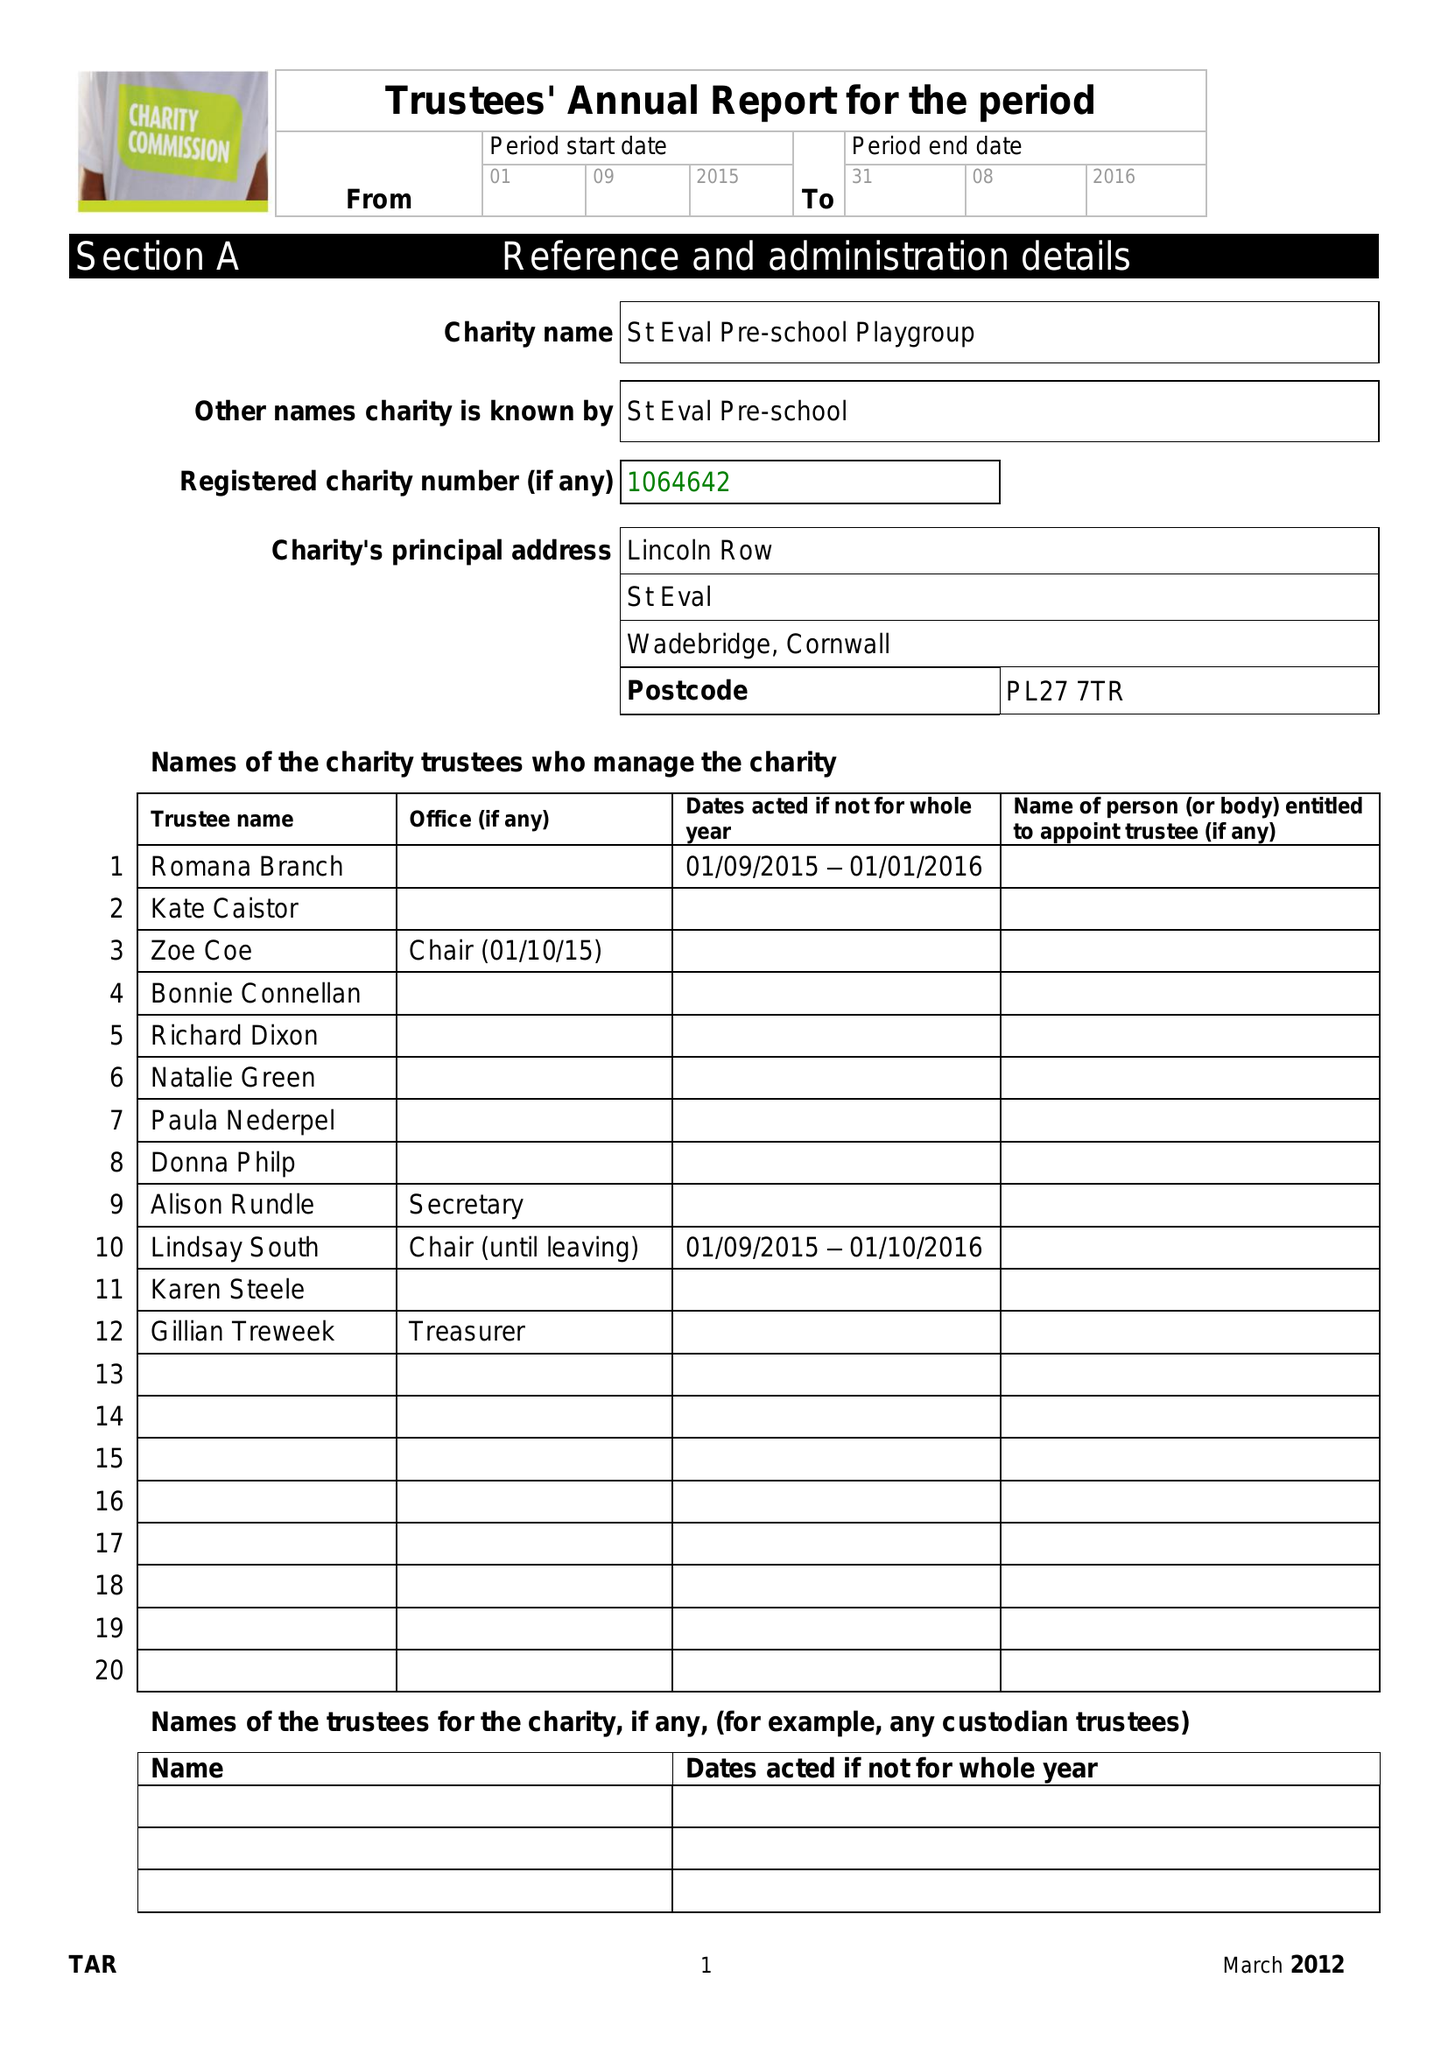What is the value for the charity_number?
Answer the question using a single word or phrase. 1064642 